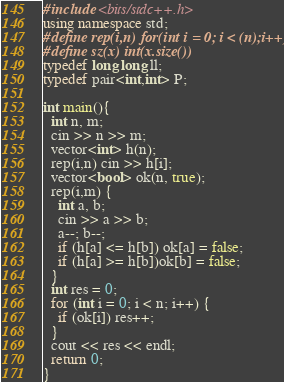<code> <loc_0><loc_0><loc_500><loc_500><_C++_>#include <bits/stdc++.h>
using namespace std;
#define rep(i,n) for(int i = 0; i < (n);i++)
#define sz(x) int(x.size())
typedef long long ll;
typedef pair<int,int> P;

int main(){ 
  int n, m;
  cin >> n >> m;
  vector<int> h(n);
  rep(i,n) cin >> h[i];
  vector<bool> ok(n, true);
  rep(i,m) {
    int a, b;
    cin >> a >> b;
    a--; b--;
    if (h[a] <= h[b]) ok[a] = false;
    if (h[a] >= h[b])ok[b] = false;
  }
  int res = 0;
  for (int i = 0; i < n; i++) {
    if (ok[i]) res++;
  }
  cout << res << endl;
  return 0;
} </code> 